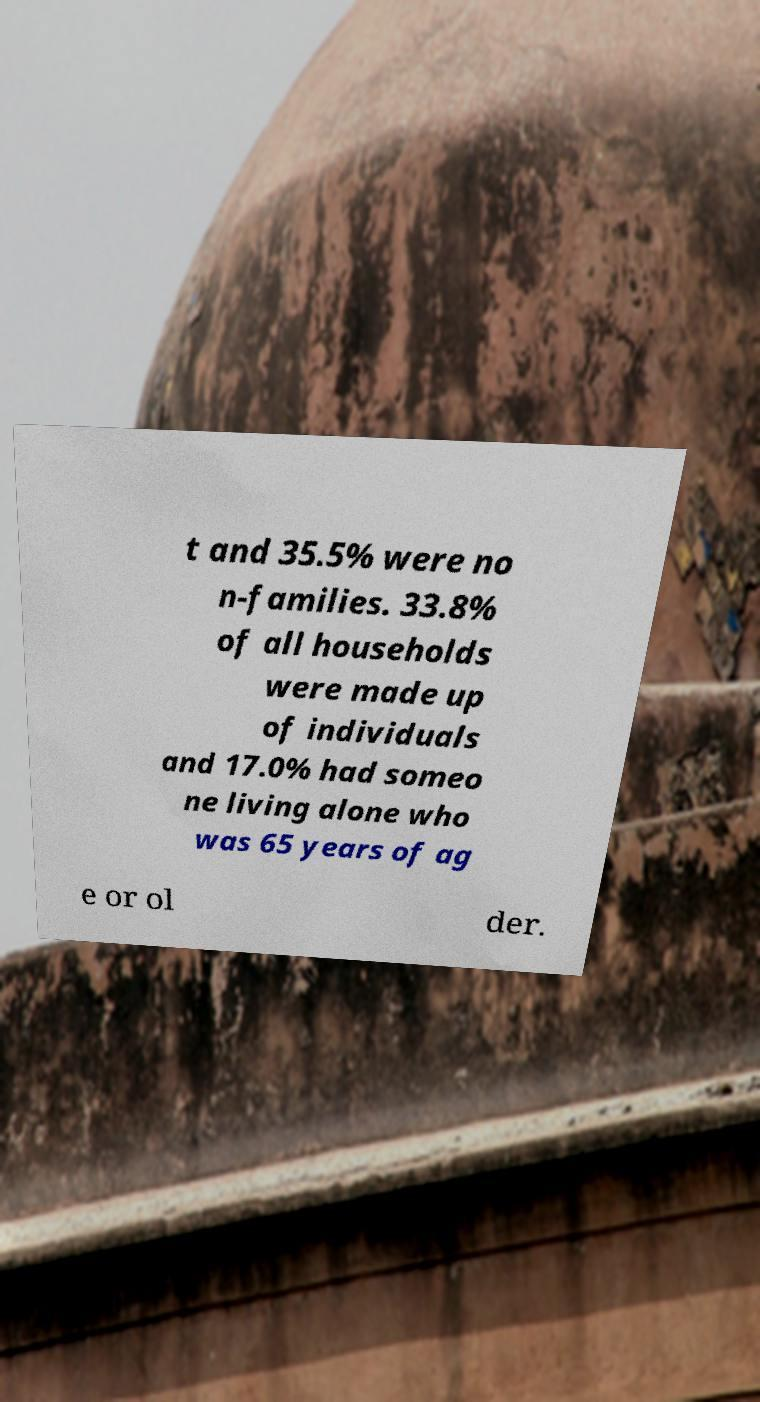Can you read and provide the text displayed in the image?This photo seems to have some interesting text. Can you extract and type it out for me? t and 35.5% were no n-families. 33.8% of all households were made up of individuals and 17.0% had someo ne living alone who was 65 years of ag e or ol der. 